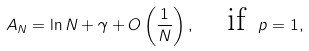Convert formula to latex. <formula><loc_0><loc_0><loc_500><loc_500>A _ { N } = \ln N + \gamma + O \left ( \frac { 1 } { N } \right ) , \quad \text {if } \, p = 1 ,</formula> 